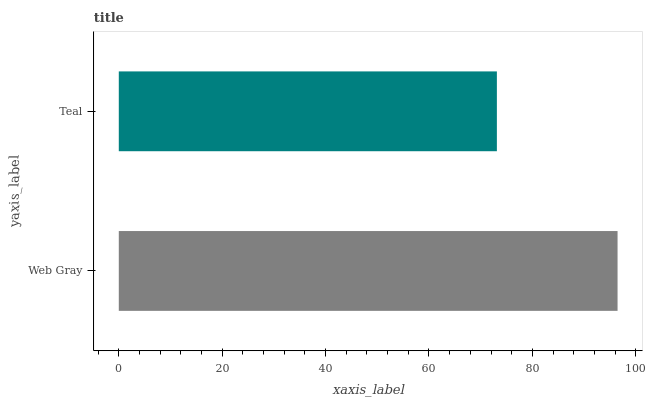Is Teal the minimum?
Answer yes or no. Yes. Is Web Gray the maximum?
Answer yes or no. Yes. Is Teal the maximum?
Answer yes or no. No. Is Web Gray greater than Teal?
Answer yes or no. Yes. Is Teal less than Web Gray?
Answer yes or no. Yes. Is Teal greater than Web Gray?
Answer yes or no. No. Is Web Gray less than Teal?
Answer yes or no. No. Is Web Gray the high median?
Answer yes or no. Yes. Is Teal the low median?
Answer yes or no. Yes. Is Teal the high median?
Answer yes or no. No. Is Web Gray the low median?
Answer yes or no. No. 